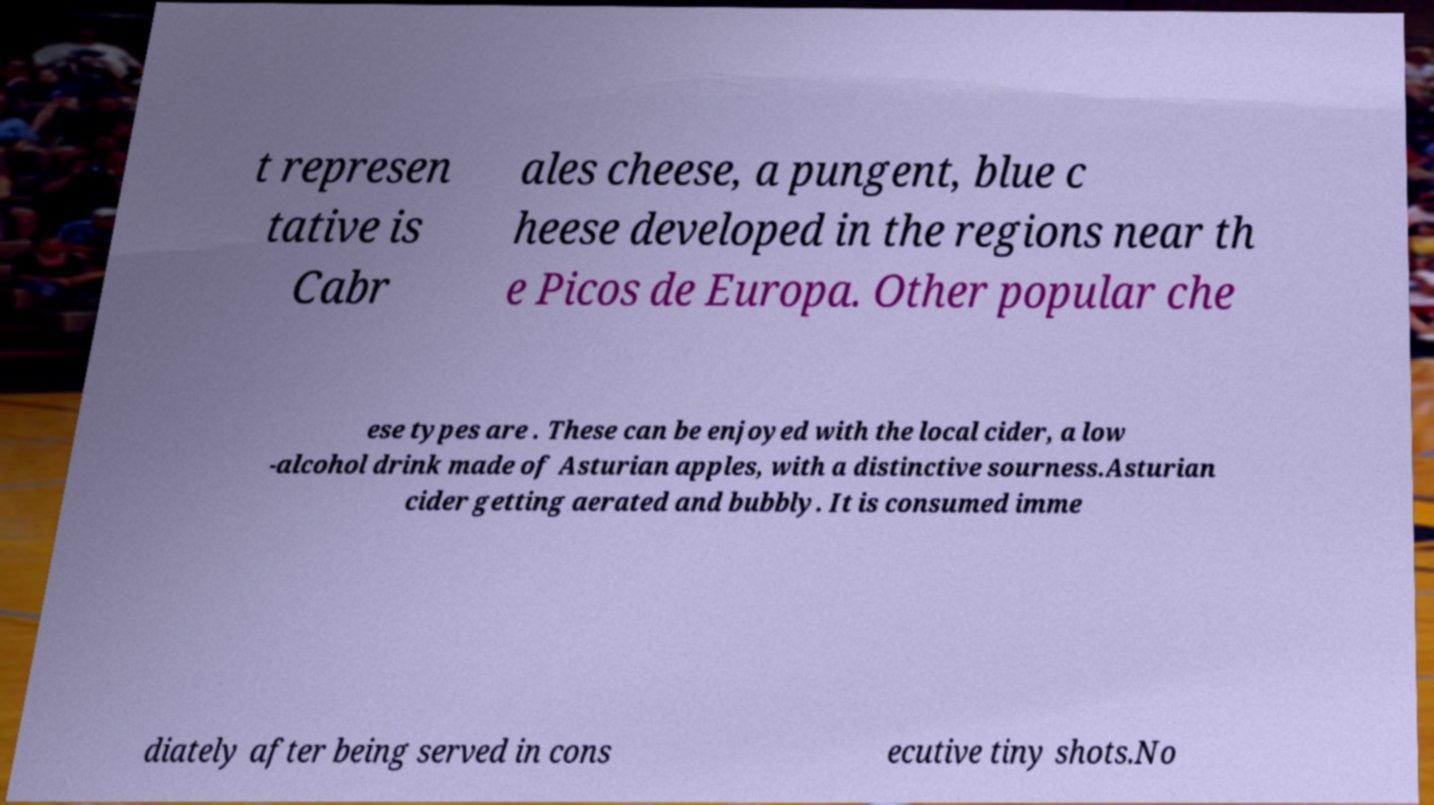I need the written content from this picture converted into text. Can you do that? t represen tative is Cabr ales cheese, a pungent, blue c heese developed in the regions near th e Picos de Europa. Other popular che ese types are . These can be enjoyed with the local cider, a low -alcohol drink made of Asturian apples, with a distinctive sourness.Asturian cider getting aerated and bubbly. It is consumed imme diately after being served in cons ecutive tiny shots.No 